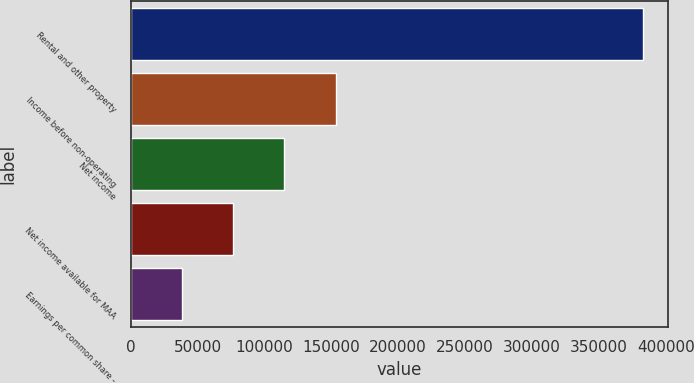Convert chart. <chart><loc_0><loc_0><loc_500><loc_500><bar_chart><fcel>Rental and other property<fcel>Income before non-operating<fcel>Net income<fcel>Net income available for MAA<fcel>Earnings per common share -<nl><fcel>382791<fcel>153117<fcel>114838<fcel>76558.5<fcel>38279.5<nl></chart> 